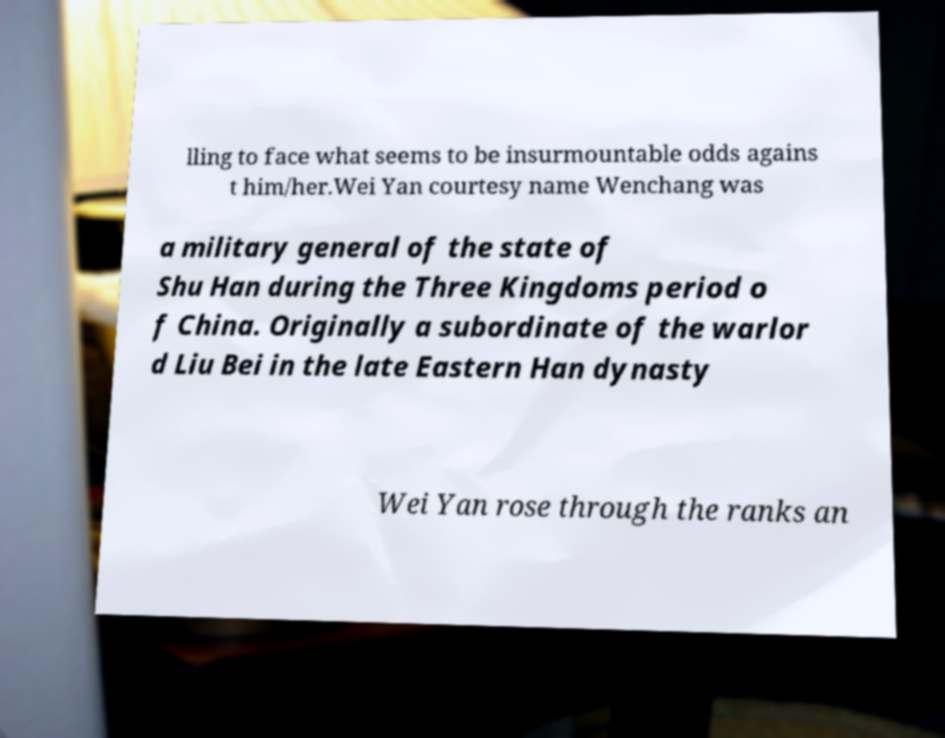What messages or text are displayed in this image? I need them in a readable, typed format. lling to face what seems to be insurmountable odds agains t him/her.Wei Yan courtesy name Wenchang was a military general of the state of Shu Han during the Three Kingdoms period o f China. Originally a subordinate of the warlor d Liu Bei in the late Eastern Han dynasty Wei Yan rose through the ranks an 